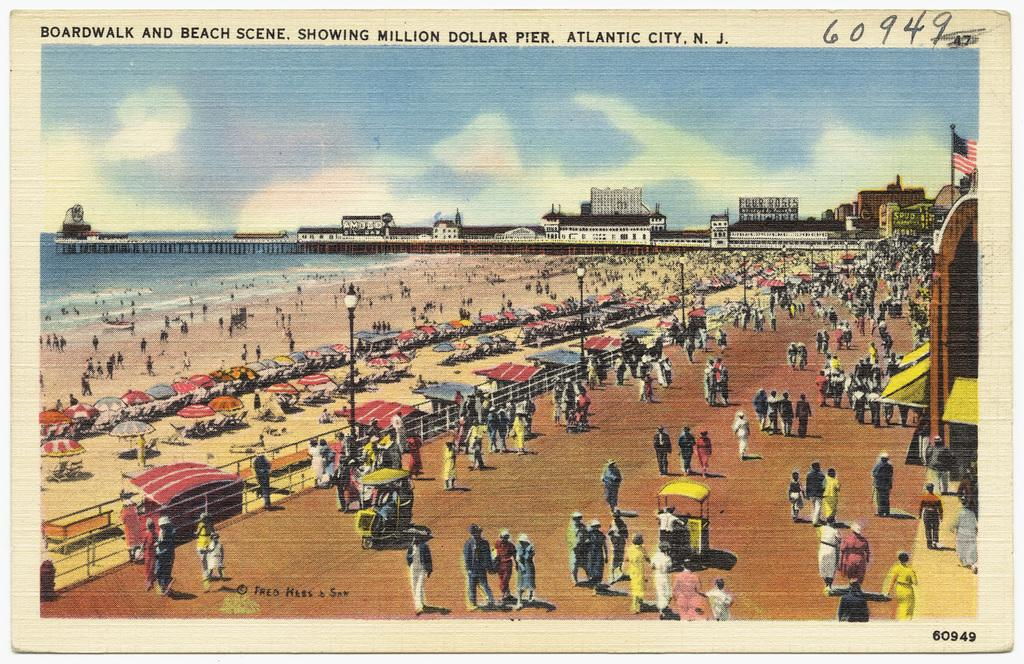What is featured on the poster in the image? The poster includes people, buildings, and fencing. What else can be seen on the poster? There is some text at the top of the poster. What is visible in the image besides the poster? There is water visible in the image, as well as lights. Can you tell me how many knives are being used by the people in the image? There are no knives visible in the image; the people are featured on the poster, not in the actual scene. What type of guide is being used by the people in the image? There is no guide present in the image; the people are featured on the poster, not in the actual scene. 